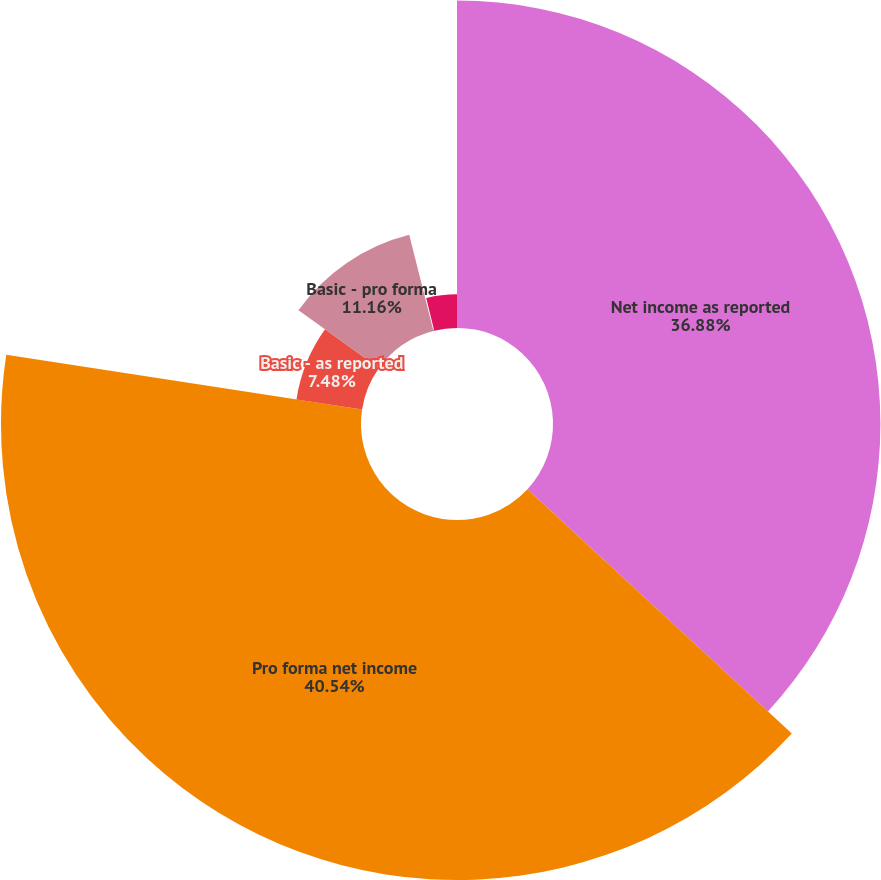Convert chart. <chart><loc_0><loc_0><loc_500><loc_500><pie_chart><fcel>Net income as reported<fcel>Pro forma net income<fcel>Basic - as reported<fcel>Basic - pro forma<fcel>Diluted - as reported<fcel>Diluted - pro forma<nl><fcel>36.88%<fcel>40.55%<fcel>7.48%<fcel>11.16%<fcel>0.13%<fcel>3.81%<nl></chart> 